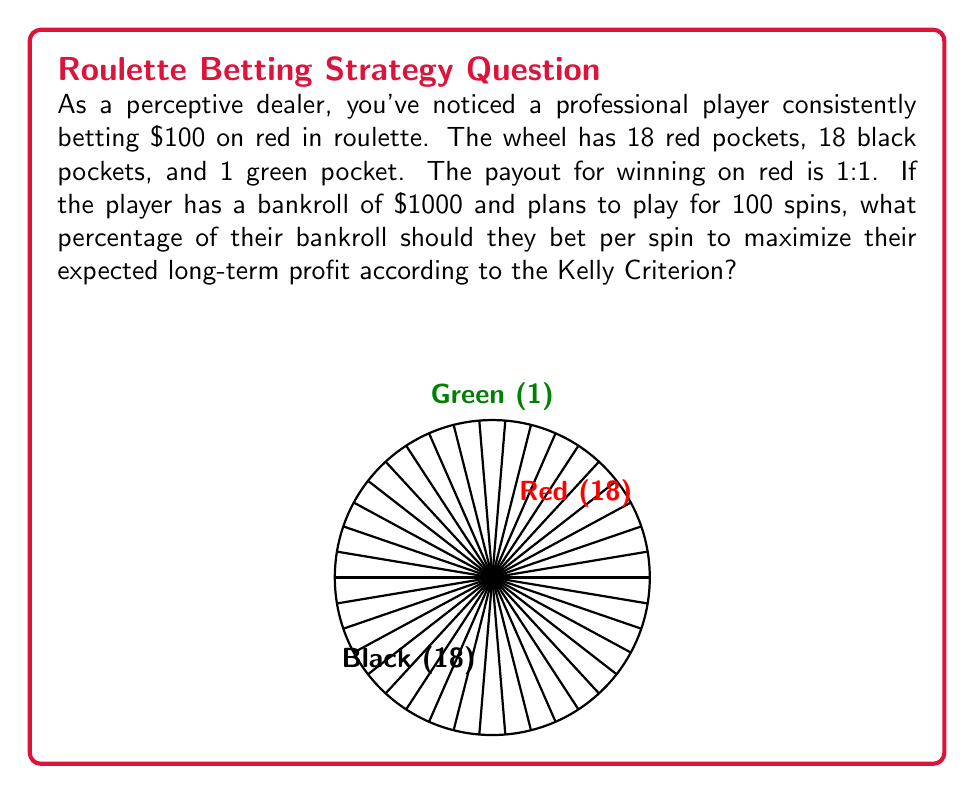Teach me how to tackle this problem. To solve this problem, we'll use the Kelly Criterion, which is a formula used to determine the optimal bet size for maximizing long-term growth. The formula is:

$$f^* = \frac{bp - q}{b}$$

Where:
$f^*$ = fraction of the bankroll to bet
$b$ = the net odds received on the bet (payout-to-1)
$p$ = probability of winning
$q$ = probability of losing (1 - p)

Step 1: Determine the probabilities
$p = \frac{18}{38} \approx 0.4737$ (probability of winning on red)
$q = 1 - p = \frac{20}{38} \approx 0.5263$ (probability of losing)

Step 2: Determine the net odds
$b = 1$ (1:1 payout)

Step 3: Apply the Kelly Criterion formula
$$f^* = \frac{1 \cdot 0.4737 - 0.5263}{1} = -0.0526$$

Step 4: Interpret the result
The negative result indicates that the game has a negative expected value, and the optimal long-term strategy is not to bet at all (i.e., bet 0% of the bankroll).

Step 5: Convert to a percentage
$0\% of bankroll$

Therefore, to maximize long-term profit (or minimize losses in this case), the player should not bet at all on this game.
Answer: $0\%$ of bankroll 